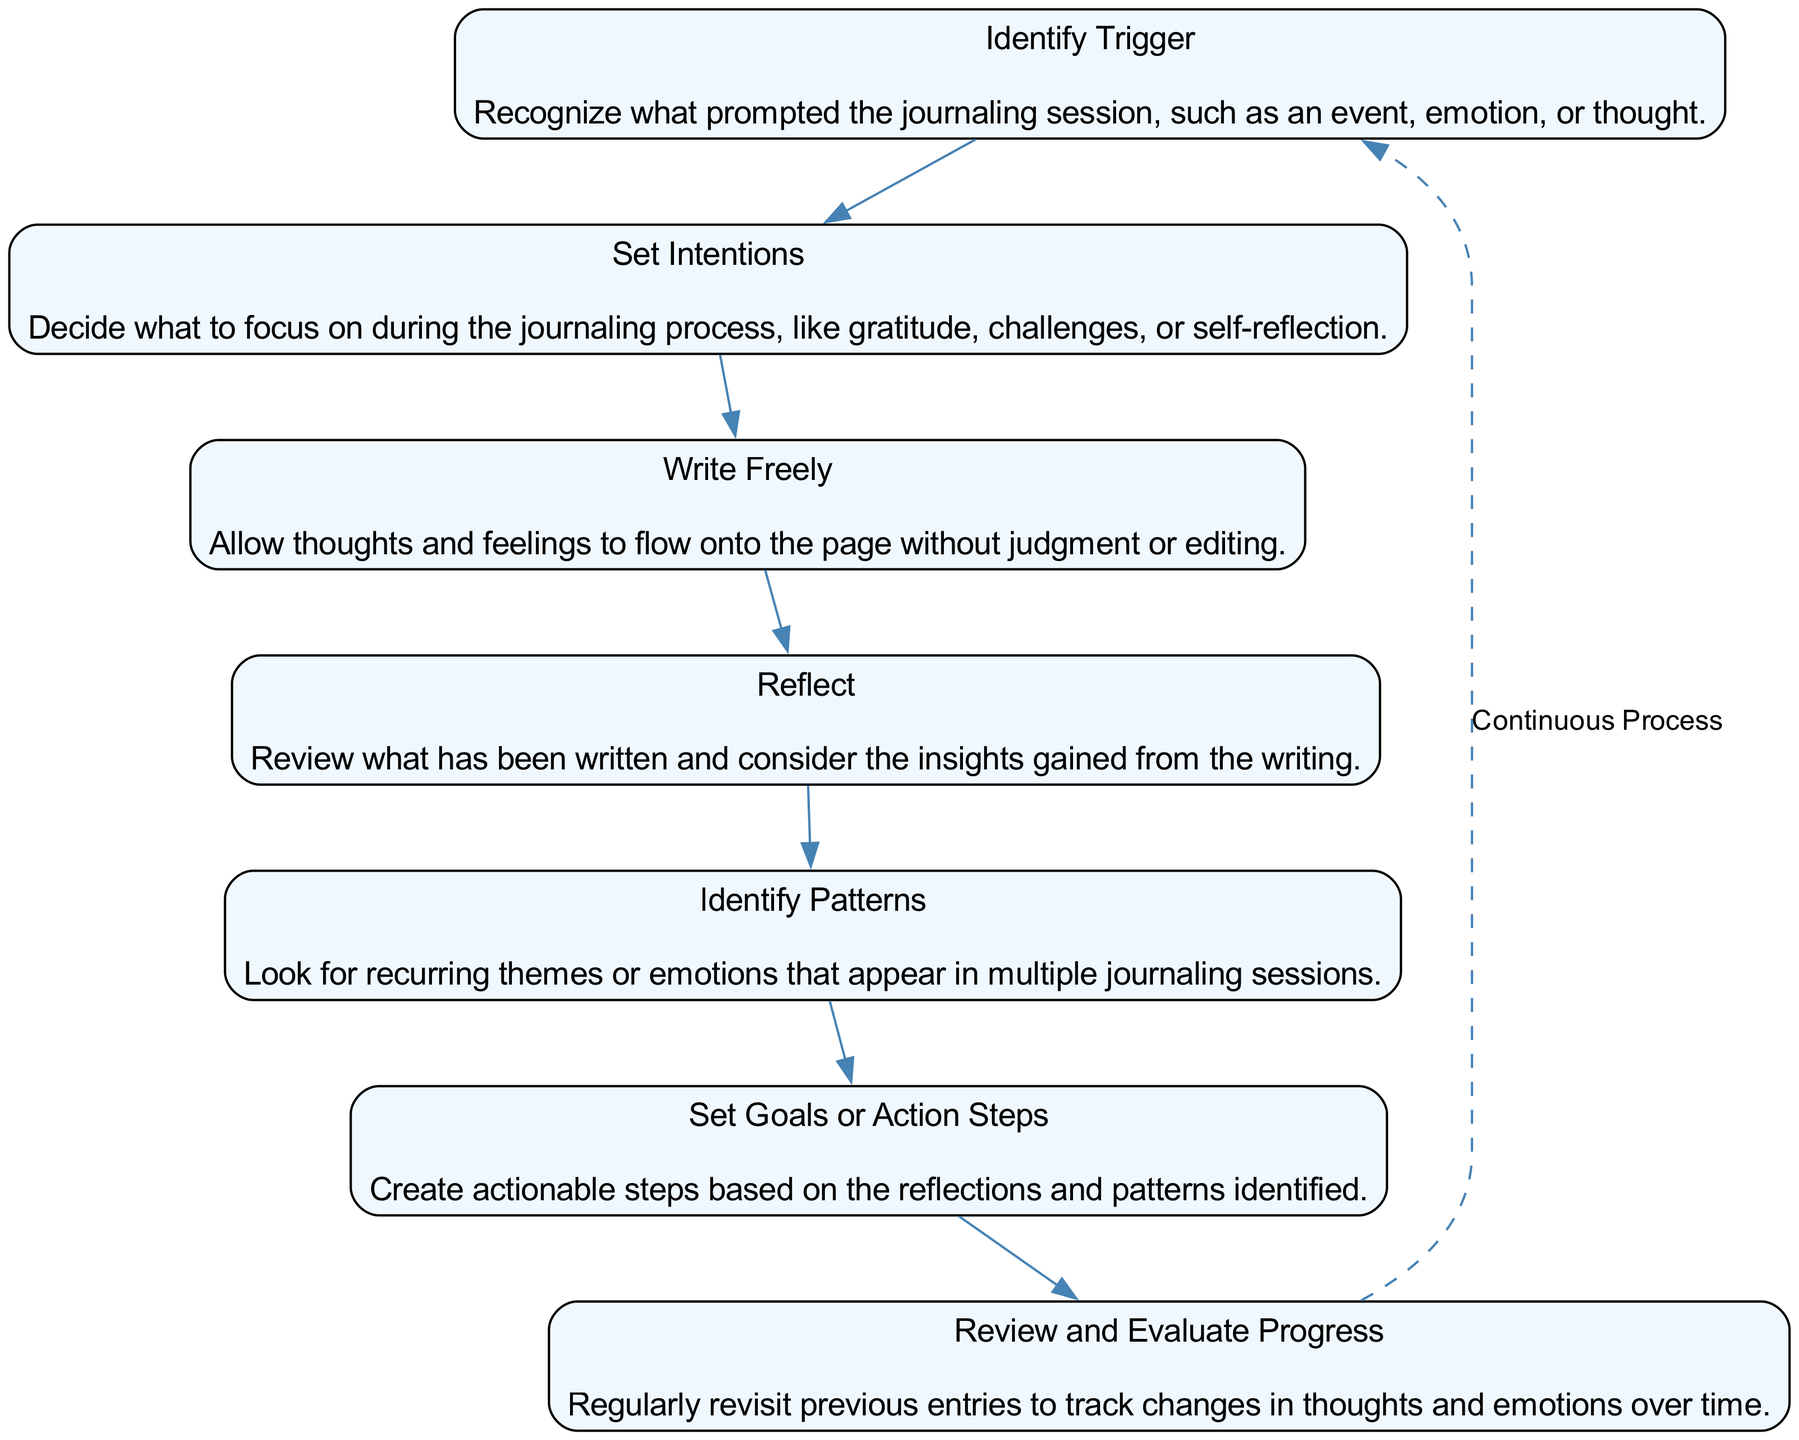What is the first step in the journaling process? The first step listed in the diagram is "Identify Trigger," which is stated as the initial node.
Answer: Identify Trigger How many steps are in the journaling process? The diagram outlines a total of seven distinct steps, identifiable by counting the nodes.
Answer: 7 What step follows "Write Freely"? "Reflect" directly follows the "Write Freely" step, as indicated by the edge connecting them in the sequence.
Answer: Reflect Which step concludes the journaling process before cycling back? The last step before cycling back to "Identify Trigger" is "Review and Evaluate Progress," as it is the final node in the sequence.
Answer: Review and Evaluate Progress What are the intentions set during the journaling process? The intention specified is to focus during the journaling process, which is described in the "Set Intentions" step.
Answer: Set Intentions What connects the last step to the first step? The connection is a dashed edge labeled "Continuous Process," indicating that the process is cyclical and ongoing.
Answer: Continuous Process In which step are patterns identified? Patterns are identified in the "Identify Patterns" step, as explicitly mentioned in the diagram.
Answer: Identify Patterns What action is taken after reflections are made? After reflection, the next action is to "Set Goals or Action Steps," which guides the participant on practical steps to take.
Answer: Set Goals or Action Steps Which step emphasizes writing without judgment? The "Write Freely" step emphasizes allowing thoughts and feelings to be expressed without judgment or editing.
Answer: Write Freely 